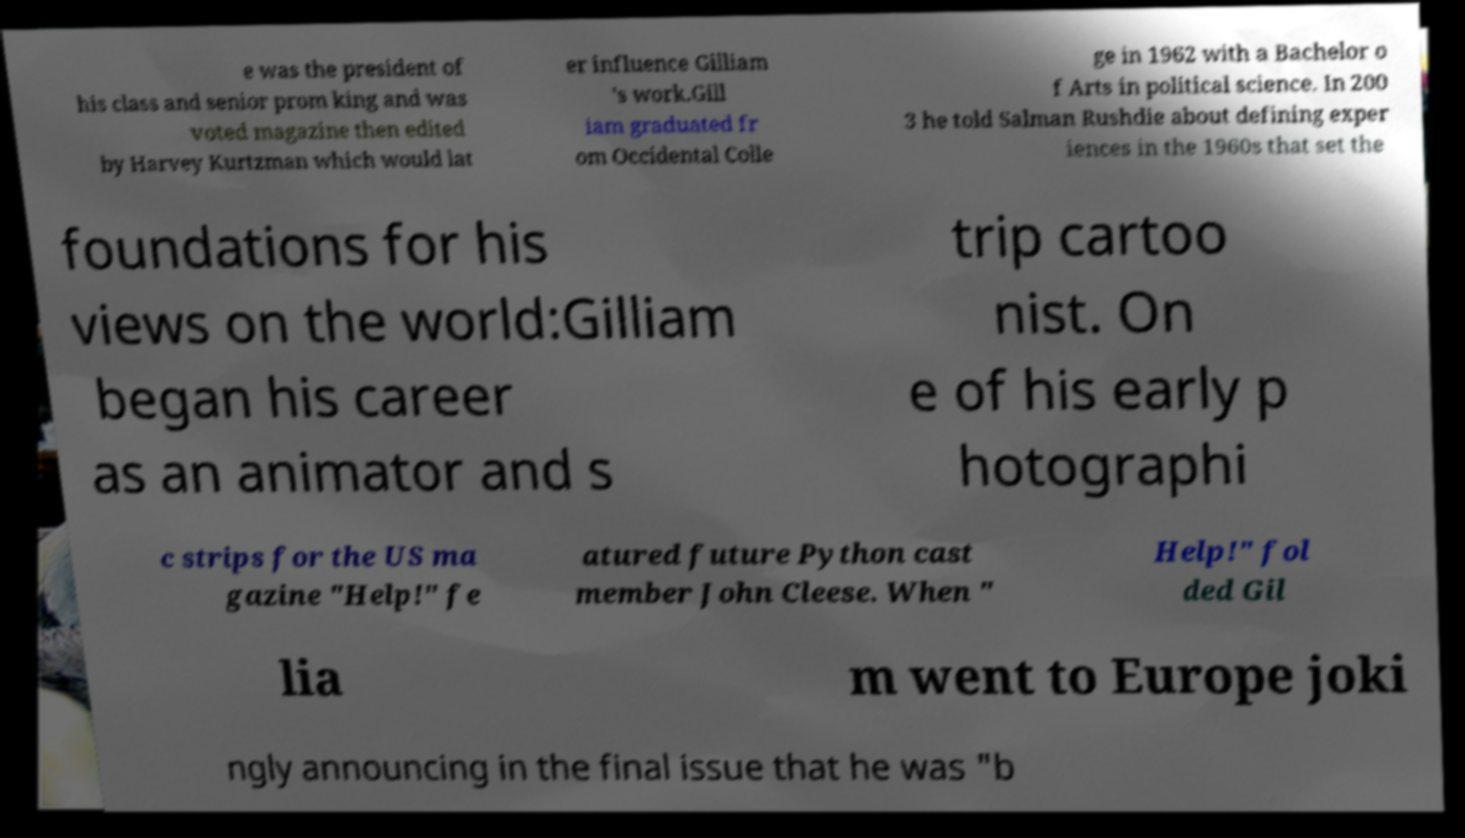For documentation purposes, I need the text within this image transcribed. Could you provide that? e was the president of his class and senior prom king and was voted magazine then edited by Harvey Kurtzman which would lat er influence Gilliam 's work.Gill iam graduated fr om Occidental Colle ge in 1962 with a Bachelor o f Arts in political science. In 200 3 he told Salman Rushdie about defining exper iences in the 1960s that set the foundations for his views on the world:Gilliam began his career as an animator and s trip cartoo nist. On e of his early p hotographi c strips for the US ma gazine "Help!" fe atured future Python cast member John Cleese. When " Help!" fol ded Gil lia m went to Europe joki ngly announcing in the final issue that he was "b 